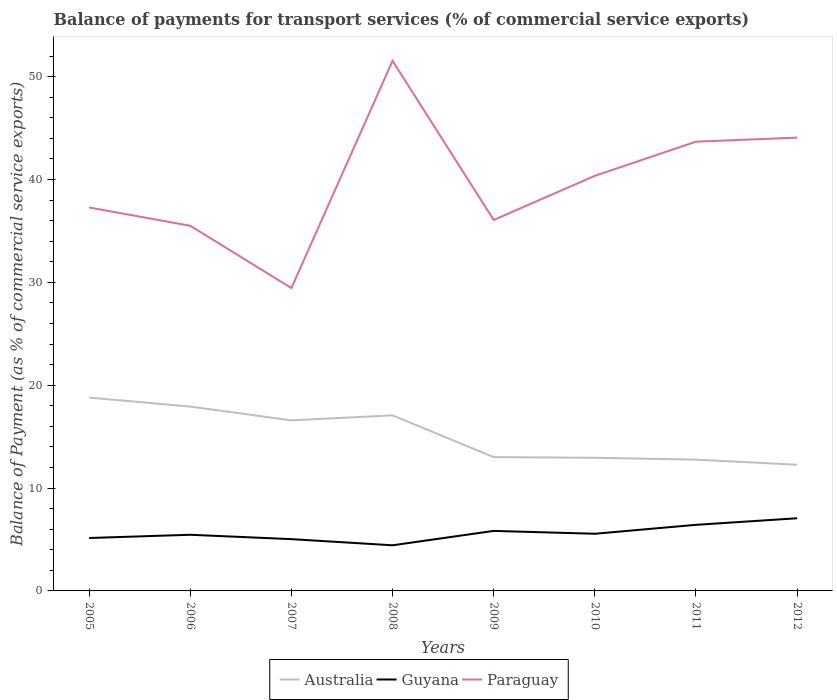How many different coloured lines are there?
Provide a succinct answer. 3. Across all years, what is the maximum balance of payments for transport services in Paraguay?
Ensure brevity in your answer.  29.45. What is the total balance of payments for transport services in Australia in the graph?
Make the answer very short. -0.49. What is the difference between the highest and the second highest balance of payments for transport services in Guyana?
Offer a very short reply. 2.63. Is the balance of payments for transport services in Guyana strictly greater than the balance of payments for transport services in Paraguay over the years?
Provide a short and direct response. Yes. How many lines are there?
Provide a succinct answer. 3. How many years are there in the graph?
Your answer should be compact. 8. What is the difference between two consecutive major ticks on the Y-axis?
Your answer should be very brief. 10. Are the values on the major ticks of Y-axis written in scientific E-notation?
Your answer should be very brief. No. Does the graph contain any zero values?
Make the answer very short. No. What is the title of the graph?
Provide a short and direct response. Balance of payments for transport services (% of commercial service exports). Does "Andorra" appear as one of the legend labels in the graph?
Keep it short and to the point. No. What is the label or title of the Y-axis?
Offer a terse response. Balance of Payment (as % of commercial service exports). What is the Balance of Payment (as % of commercial service exports) in Australia in 2005?
Provide a succinct answer. 18.8. What is the Balance of Payment (as % of commercial service exports) in Guyana in 2005?
Make the answer very short. 5.15. What is the Balance of Payment (as % of commercial service exports) of Paraguay in 2005?
Provide a succinct answer. 37.28. What is the Balance of Payment (as % of commercial service exports) in Australia in 2006?
Your response must be concise. 17.92. What is the Balance of Payment (as % of commercial service exports) in Guyana in 2006?
Make the answer very short. 5.46. What is the Balance of Payment (as % of commercial service exports) in Paraguay in 2006?
Your answer should be compact. 35.5. What is the Balance of Payment (as % of commercial service exports) of Australia in 2007?
Ensure brevity in your answer.  16.58. What is the Balance of Payment (as % of commercial service exports) of Guyana in 2007?
Offer a terse response. 5.03. What is the Balance of Payment (as % of commercial service exports) in Paraguay in 2007?
Provide a succinct answer. 29.45. What is the Balance of Payment (as % of commercial service exports) in Australia in 2008?
Provide a short and direct response. 17.07. What is the Balance of Payment (as % of commercial service exports) of Guyana in 2008?
Ensure brevity in your answer.  4.44. What is the Balance of Payment (as % of commercial service exports) of Paraguay in 2008?
Offer a very short reply. 51.54. What is the Balance of Payment (as % of commercial service exports) in Australia in 2009?
Provide a succinct answer. 13.01. What is the Balance of Payment (as % of commercial service exports) of Guyana in 2009?
Offer a very short reply. 5.84. What is the Balance of Payment (as % of commercial service exports) in Paraguay in 2009?
Provide a succinct answer. 36.07. What is the Balance of Payment (as % of commercial service exports) in Australia in 2010?
Provide a succinct answer. 12.94. What is the Balance of Payment (as % of commercial service exports) of Guyana in 2010?
Your answer should be very brief. 5.56. What is the Balance of Payment (as % of commercial service exports) in Paraguay in 2010?
Keep it short and to the point. 40.36. What is the Balance of Payment (as % of commercial service exports) of Australia in 2011?
Your response must be concise. 12.76. What is the Balance of Payment (as % of commercial service exports) in Guyana in 2011?
Keep it short and to the point. 6.43. What is the Balance of Payment (as % of commercial service exports) of Paraguay in 2011?
Offer a terse response. 43.68. What is the Balance of Payment (as % of commercial service exports) of Australia in 2012?
Your answer should be compact. 12.27. What is the Balance of Payment (as % of commercial service exports) in Guyana in 2012?
Offer a terse response. 7.06. What is the Balance of Payment (as % of commercial service exports) in Paraguay in 2012?
Give a very brief answer. 44.07. Across all years, what is the maximum Balance of Payment (as % of commercial service exports) of Australia?
Provide a short and direct response. 18.8. Across all years, what is the maximum Balance of Payment (as % of commercial service exports) of Guyana?
Ensure brevity in your answer.  7.06. Across all years, what is the maximum Balance of Payment (as % of commercial service exports) in Paraguay?
Your answer should be very brief. 51.54. Across all years, what is the minimum Balance of Payment (as % of commercial service exports) of Australia?
Your answer should be very brief. 12.27. Across all years, what is the minimum Balance of Payment (as % of commercial service exports) of Guyana?
Offer a terse response. 4.44. Across all years, what is the minimum Balance of Payment (as % of commercial service exports) of Paraguay?
Offer a terse response. 29.45. What is the total Balance of Payment (as % of commercial service exports) of Australia in the graph?
Give a very brief answer. 121.36. What is the total Balance of Payment (as % of commercial service exports) of Guyana in the graph?
Give a very brief answer. 44.96. What is the total Balance of Payment (as % of commercial service exports) in Paraguay in the graph?
Your response must be concise. 317.95. What is the difference between the Balance of Payment (as % of commercial service exports) in Australia in 2005 and that in 2006?
Offer a very short reply. 0.87. What is the difference between the Balance of Payment (as % of commercial service exports) in Guyana in 2005 and that in 2006?
Provide a succinct answer. -0.31. What is the difference between the Balance of Payment (as % of commercial service exports) of Paraguay in 2005 and that in 2006?
Provide a succinct answer. 1.78. What is the difference between the Balance of Payment (as % of commercial service exports) of Australia in 2005 and that in 2007?
Your answer should be compact. 2.21. What is the difference between the Balance of Payment (as % of commercial service exports) of Guyana in 2005 and that in 2007?
Give a very brief answer. 0.11. What is the difference between the Balance of Payment (as % of commercial service exports) of Paraguay in 2005 and that in 2007?
Give a very brief answer. 7.84. What is the difference between the Balance of Payment (as % of commercial service exports) of Australia in 2005 and that in 2008?
Your answer should be compact. 1.73. What is the difference between the Balance of Payment (as % of commercial service exports) in Guyana in 2005 and that in 2008?
Your response must be concise. 0.71. What is the difference between the Balance of Payment (as % of commercial service exports) of Paraguay in 2005 and that in 2008?
Your answer should be compact. -14.26. What is the difference between the Balance of Payment (as % of commercial service exports) of Australia in 2005 and that in 2009?
Give a very brief answer. 5.79. What is the difference between the Balance of Payment (as % of commercial service exports) of Guyana in 2005 and that in 2009?
Keep it short and to the point. -0.69. What is the difference between the Balance of Payment (as % of commercial service exports) of Paraguay in 2005 and that in 2009?
Keep it short and to the point. 1.21. What is the difference between the Balance of Payment (as % of commercial service exports) in Australia in 2005 and that in 2010?
Ensure brevity in your answer.  5.85. What is the difference between the Balance of Payment (as % of commercial service exports) of Guyana in 2005 and that in 2010?
Your answer should be very brief. -0.41. What is the difference between the Balance of Payment (as % of commercial service exports) in Paraguay in 2005 and that in 2010?
Give a very brief answer. -3.08. What is the difference between the Balance of Payment (as % of commercial service exports) of Australia in 2005 and that in 2011?
Make the answer very short. 6.03. What is the difference between the Balance of Payment (as % of commercial service exports) in Guyana in 2005 and that in 2011?
Offer a very short reply. -1.28. What is the difference between the Balance of Payment (as % of commercial service exports) in Paraguay in 2005 and that in 2011?
Give a very brief answer. -6.4. What is the difference between the Balance of Payment (as % of commercial service exports) in Australia in 2005 and that in 2012?
Ensure brevity in your answer.  6.53. What is the difference between the Balance of Payment (as % of commercial service exports) in Guyana in 2005 and that in 2012?
Your response must be concise. -1.92. What is the difference between the Balance of Payment (as % of commercial service exports) in Paraguay in 2005 and that in 2012?
Keep it short and to the point. -6.79. What is the difference between the Balance of Payment (as % of commercial service exports) in Australia in 2006 and that in 2007?
Give a very brief answer. 1.34. What is the difference between the Balance of Payment (as % of commercial service exports) of Guyana in 2006 and that in 2007?
Offer a very short reply. 0.42. What is the difference between the Balance of Payment (as % of commercial service exports) of Paraguay in 2006 and that in 2007?
Offer a very short reply. 6.06. What is the difference between the Balance of Payment (as % of commercial service exports) in Australia in 2006 and that in 2008?
Keep it short and to the point. 0.85. What is the difference between the Balance of Payment (as % of commercial service exports) in Guyana in 2006 and that in 2008?
Provide a short and direct response. 1.02. What is the difference between the Balance of Payment (as % of commercial service exports) of Paraguay in 2006 and that in 2008?
Your response must be concise. -16.04. What is the difference between the Balance of Payment (as % of commercial service exports) in Australia in 2006 and that in 2009?
Provide a succinct answer. 4.91. What is the difference between the Balance of Payment (as % of commercial service exports) of Guyana in 2006 and that in 2009?
Offer a very short reply. -0.38. What is the difference between the Balance of Payment (as % of commercial service exports) of Paraguay in 2006 and that in 2009?
Give a very brief answer. -0.56. What is the difference between the Balance of Payment (as % of commercial service exports) in Australia in 2006 and that in 2010?
Provide a short and direct response. 4.98. What is the difference between the Balance of Payment (as % of commercial service exports) in Guyana in 2006 and that in 2010?
Provide a short and direct response. -0.1. What is the difference between the Balance of Payment (as % of commercial service exports) in Paraguay in 2006 and that in 2010?
Your response must be concise. -4.85. What is the difference between the Balance of Payment (as % of commercial service exports) of Australia in 2006 and that in 2011?
Your answer should be compact. 5.16. What is the difference between the Balance of Payment (as % of commercial service exports) in Guyana in 2006 and that in 2011?
Offer a very short reply. -0.97. What is the difference between the Balance of Payment (as % of commercial service exports) in Paraguay in 2006 and that in 2011?
Give a very brief answer. -8.18. What is the difference between the Balance of Payment (as % of commercial service exports) in Australia in 2006 and that in 2012?
Your response must be concise. 5.65. What is the difference between the Balance of Payment (as % of commercial service exports) in Guyana in 2006 and that in 2012?
Make the answer very short. -1.61. What is the difference between the Balance of Payment (as % of commercial service exports) in Paraguay in 2006 and that in 2012?
Your answer should be very brief. -8.57. What is the difference between the Balance of Payment (as % of commercial service exports) of Australia in 2007 and that in 2008?
Provide a short and direct response. -0.49. What is the difference between the Balance of Payment (as % of commercial service exports) in Guyana in 2007 and that in 2008?
Provide a succinct answer. 0.6. What is the difference between the Balance of Payment (as % of commercial service exports) in Paraguay in 2007 and that in 2008?
Your response must be concise. -22.09. What is the difference between the Balance of Payment (as % of commercial service exports) in Australia in 2007 and that in 2009?
Provide a short and direct response. 3.57. What is the difference between the Balance of Payment (as % of commercial service exports) in Guyana in 2007 and that in 2009?
Ensure brevity in your answer.  -0.8. What is the difference between the Balance of Payment (as % of commercial service exports) in Paraguay in 2007 and that in 2009?
Provide a short and direct response. -6.62. What is the difference between the Balance of Payment (as % of commercial service exports) of Australia in 2007 and that in 2010?
Give a very brief answer. 3.64. What is the difference between the Balance of Payment (as % of commercial service exports) of Guyana in 2007 and that in 2010?
Ensure brevity in your answer.  -0.52. What is the difference between the Balance of Payment (as % of commercial service exports) in Paraguay in 2007 and that in 2010?
Your answer should be very brief. -10.91. What is the difference between the Balance of Payment (as % of commercial service exports) of Australia in 2007 and that in 2011?
Your answer should be compact. 3.82. What is the difference between the Balance of Payment (as % of commercial service exports) of Guyana in 2007 and that in 2011?
Keep it short and to the point. -1.39. What is the difference between the Balance of Payment (as % of commercial service exports) in Paraguay in 2007 and that in 2011?
Your response must be concise. -14.23. What is the difference between the Balance of Payment (as % of commercial service exports) in Australia in 2007 and that in 2012?
Offer a very short reply. 4.31. What is the difference between the Balance of Payment (as % of commercial service exports) in Guyana in 2007 and that in 2012?
Give a very brief answer. -2.03. What is the difference between the Balance of Payment (as % of commercial service exports) in Paraguay in 2007 and that in 2012?
Your answer should be very brief. -14.62. What is the difference between the Balance of Payment (as % of commercial service exports) of Australia in 2008 and that in 2009?
Provide a short and direct response. 4.06. What is the difference between the Balance of Payment (as % of commercial service exports) in Guyana in 2008 and that in 2009?
Ensure brevity in your answer.  -1.4. What is the difference between the Balance of Payment (as % of commercial service exports) in Paraguay in 2008 and that in 2009?
Your answer should be very brief. 15.47. What is the difference between the Balance of Payment (as % of commercial service exports) in Australia in 2008 and that in 2010?
Provide a short and direct response. 4.12. What is the difference between the Balance of Payment (as % of commercial service exports) of Guyana in 2008 and that in 2010?
Your answer should be compact. -1.12. What is the difference between the Balance of Payment (as % of commercial service exports) of Paraguay in 2008 and that in 2010?
Your answer should be very brief. 11.18. What is the difference between the Balance of Payment (as % of commercial service exports) of Australia in 2008 and that in 2011?
Your answer should be very brief. 4.31. What is the difference between the Balance of Payment (as % of commercial service exports) of Guyana in 2008 and that in 2011?
Provide a short and direct response. -1.99. What is the difference between the Balance of Payment (as % of commercial service exports) in Paraguay in 2008 and that in 2011?
Keep it short and to the point. 7.86. What is the difference between the Balance of Payment (as % of commercial service exports) of Australia in 2008 and that in 2012?
Offer a very short reply. 4.8. What is the difference between the Balance of Payment (as % of commercial service exports) in Guyana in 2008 and that in 2012?
Your answer should be very brief. -2.63. What is the difference between the Balance of Payment (as % of commercial service exports) of Paraguay in 2008 and that in 2012?
Provide a short and direct response. 7.47. What is the difference between the Balance of Payment (as % of commercial service exports) of Australia in 2009 and that in 2010?
Make the answer very short. 0.06. What is the difference between the Balance of Payment (as % of commercial service exports) of Guyana in 2009 and that in 2010?
Offer a terse response. 0.28. What is the difference between the Balance of Payment (as % of commercial service exports) in Paraguay in 2009 and that in 2010?
Your response must be concise. -4.29. What is the difference between the Balance of Payment (as % of commercial service exports) in Australia in 2009 and that in 2011?
Provide a succinct answer. 0.25. What is the difference between the Balance of Payment (as % of commercial service exports) of Guyana in 2009 and that in 2011?
Your answer should be compact. -0.59. What is the difference between the Balance of Payment (as % of commercial service exports) of Paraguay in 2009 and that in 2011?
Provide a succinct answer. -7.61. What is the difference between the Balance of Payment (as % of commercial service exports) of Australia in 2009 and that in 2012?
Ensure brevity in your answer.  0.74. What is the difference between the Balance of Payment (as % of commercial service exports) in Guyana in 2009 and that in 2012?
Ensure brevity in your answer.  -1.23. What is the difference between the Balance of Payment (as % of commercial service exports) in Paraguay in 2009 and that in 2012?
Give a very brief answer. -8. What is the difference between the Balance of Payment (as % of commercial service exports) of Australia in 2010 and that in 2011?
Your answer should be compact. 0.18. What is the difference between the Balance of Payment (as % of commercial service exports) in Guyana in 2010 and that in 2011?
Offer a terse response. -0.87. What is the difference between the Balance of Payment (as % of commercial service exports) of Paraguay in 2010 and that in 2011?
Offer a terse response. -3.32. What is the difference between the Balance of Payment (as % of commercial service exports) in Australia in 2010 and that in 2012?
Keep it short and to the point. 0.68. What is the difference between the Balance of Payment (as % of commercial service exports) in Guyana in 2010 and that in 2012?
Your answer should be compact. -1.51. What is the difference between the Balance of Payment (as % of commercial service exports) in Paraguay in 2010 and that in 2012?
Make the answer very short. -3.71. What is the difference between the Balance of Payment (as % of commercial service exports) in Australia in 2011 and that in 2012?
Your response must be concise. 0.49. What is the difference between the Balance of Payment (as % of commercial service exports) of Guyana in 2011 and that in 2012?
Your answer should be very brief. -0.64. What is the difference between the Balance of Payment (as % of commercial service exports) of Paraguay in 2011 and that in 2012?
Your answer should be compact. -0.39. What is the difference between the Balance of Payment (as % of commercial service exports) of Australia in 2005 and the Balance of Payment (as % of commercial service exports) of Guyana in 2006?
Provide a succinct answer. 13.34. What is the difference between the Balance of Payment (as % of commercial service exports) of Australia in 2005 and the Balance of Payment (as % of commercial service exports) of Paraguay in 2006?
Ensure brevity in your answer.  -16.71. What is the difference between the Balance of Payment (as % of commercial service exports) of Guyana in 2005 and the Balance of Payment (as % of commercial service exports) of Paraguay in 2006?
Ensure brevity in your answer.  -30.36. What is the difference between the Balance of Payment (as % of commercial service exports) of Australia in 2005 and the Balance of Payment (as % of commercial service exports) of Guyana in 2007?
Give a very brief answer. 13.76. What is the difference between the Balance of Payment (as % of commercial service exports) of Australia in 2005 and the Balance of Payment (as % of commercial service exports) of Paraguay in 2007?
Provide a succinct answer. -10.65. What is the difference between the Balance of Payment (as % of commercial service exports) in Guyana in 2005 and the Balance of Payment (as % of commercial service exports) in Paraguay in 2007?
Your answer should be compact. -24.3. What is the difference between the Balance of Payment (as % of commercial service exports) of Australia in 2005 and the Balance of Payment (as % of commercial service exports) of Guyana in 2008?
Offer a very short reply. 14.36. What is the difference between the Balance of Payment (as % of commercial service exports) in Australia in 2005 and the Balance of Payment (as % of commercial service exports) in Paraguay in 2008?
Offer a terse response. -32.74. What is the difference between the Balance of Payment (as % of commercial service exports) of Guyana in 2005 and the Balance of Payment (as % of commercial service exports) of Paraguay in 2008?
Ensure brevity in your answer.  -46.4. What is the difference between the Balance of Payment (as % of commercial service exports) in Australia in 2005 and the Balance of Payment (as % of commercial service exports) in Guyana in 2009?
Your answer should be compact. 12.96. What is the difference between the Balance of Payment (as % of commercial service exports) in Australia in 2005 and the Balance of Payment (as % of commercial service exports) in Paraguay in 2009?
Offer a very short reply. -17.27. What is the difference between the Balance of Payment (as % of commercial service exports) in Guyana in 2005 and the Balance of Payment (as % of commercial service exports) in Paraguay in 2009?
Make the answer very short. -30.92. What is the difference between the Balance of Payment (as % of commercial service exports) of Australia in 2005 and the Balance of Payment (as % of commercial service exports) of Guyana in 2010?
Your answer should be very brief. 13.24. What is the difference between the Balance of Payment (as % of commercial service exports) in Australia in 2005 and the Balance of Payment (as % of commercial service exports) in Paraguay in 2010?
Keep it short and to the point. -21.56. What is the difference between the Balance of Payment (as % of commercial service exports) in Guyana in 2005 and the Balance of Payment (as % of commercial service exports) in Paraguay in 2010?
Your response must be concise. -35.21. What is the difference between the Balance of Payment (as % of commercial service exports) in Australia in 2005 and the Balance of Payment (as % of commercial service exports) in Guyana in 2011?
Give a very brief answer. 12.37. What is the difference between the Balance of Payment (as % of commercial service exports) of Australia in 2005 and the Balance of Payment (as % of commercial service exports) of Paraguay in 2011?
Provide a succinct answer. -24.88. What is the difference between the Balance of Payment (as % of commercial service exports) of Guyana in 2005 and the Balance of Payment (as % of commercial service exports) of Paraguay in 2011?
Offer a terse response. -38.53. What is the difference between the Balance of Payment (as % of commercial service exports) of Australia in 2005 and the Balance of Payment (as % of commercial service exports) of Guyana in 2012?
Provide a succinct answer. 11.73. What is the difference between the Balance of Payment (as % of commercial service exports) of Australia in 2005 and the Balance of Payment (as % of commercial service exports) of Paraguay in 2012?
Provide a succinct answer. -25.28. What is the difference between the Balance of Payment (as % of commercial service exports) of Guyana in 2005 and the Balance of Payment (as % of commercial service exports) of Paraguay in 2012?
Your answer should be very brief. -38.93. What is the difference between the Balance of Payment (as % of commercial service exports) in Australia in 2006 and the Balance of Payment (as % of commercial service exports) in Guyana in 2007?
Keep it short and to the point. 12.89. What is the difference between the Balance of Payment (as % of commercial service exports) of Australia in 2006 and the Balance of Payment (as % of commercial service exports) of Paraguay in 2007?
Your answer should be compact. -11.52. What is the difference between the Balance of Payment (as % of commercial service exports) in Guyana in 2006 and the Balance of Payment (as % of commercial service exports) in Paraguay in 2007?
Keep it short and to the point. -23.99. What is the difference between the Balance of Payment (as % of commercial service exports) in Australia in 2006 and the Balance of Payment (as % of commercial service exports) in Guyana in 2008?
Provide a succinct answer. 13.49. What is the difference between the Balance of Payment (as % of commercial service exports) of Australia in 2006 and the Balance of Payment (as % of commercial service exports) of Paraguay in 2008?
Your answer should be very brief. -33.62. What is the difference between the Balance of Payment (as % of commercial service exports) in Guyana in 2006 and the Balance of Payment (as % of commercial service exports) in Paraguay in 2008?
Ensure brevity in your answer.  -46.08. What is the difference between the Balance of Payment (as % of commercial service exports) in Australia in 2006 and the Balance of Payment (as % of commercial service exports) in Guyana in 2009?
Your response must be concise. 12.09. What is the difference between the Balance of Payment (as % of commercial service exports) in Australia in 2006 and the Balance of Payment (as % of commercial service exports) in Paraguay in 2009?
Make the answer very short. -18.14. What is the difference between the Balance of Payment (as % of commercial service exports) in Guyana in 2006 and the Balance of Payment (as % of commercial service exports) in Paraguay in 2009?
Provide a succinct answer. -30.61. What is the difference between the Balance of Payment (as % of commercial service exports) in Australia in 2006 and the Balance of Payment (as % of commercial service exports) in Guyana in 2010?
Give a very brief answer. 12.37. What is the difference between the Balance of Payment (as % of commercial service exports) of Australia in 2006 and the Balance of Payment (as % of commercial service exports) of Paraguay in 2010?
Give a very brief answer. -22.43. What is the difference between the Balance of Payment (as % of commercial service exports) in Guyana in 2006 and the Balance of Payment (as % of commercial service exports) in Paraguay in 2010?
Keep it short and to the point. -34.9. What is the difference between the Balance of Payment (as % of commercial service exports) of Australia in 2006 and the Balance of Payment (as % of commercial service exports) of Guyana in 2011?
Give a very brief answer. 11.5. What is the difference between the Balance of Payment (as % of commercial service exports) in Australia in 2006 and the Balance of Payment (as % of commercial service exports) in Paraguay in 2011?
Provide a short and direct response. -25.76. What is the difference between the Balance of Payment (as % of commercial service exports) of Guyana in 2006 and the Balance of Payment (as % of commercial service exports) of Paraguay in 2011?
Offer a terse response. -38.22. What is the difference between the Balance of Payment (as % of commercial service exports) in Australia in 2006 and the Balance of Payment (as % of commercial service exports) in Guyana in 2012?
Make the answer very short. 10.86. What is the difference between the Balance of Payment (as % of commercial service exports) of Australia in 2006 and the Balance of Payment (as % of commercial service exports) of Paraguay in 2012?
Your answer should be compact. -26.15. What is the difference between the Balance of Payment (as % of commercial service exports) in Guyana in 2006 and the Balance of Payment (as % of commercial service exports) in Paraguay in 2012?
Keep it short and to the point. -38.61. What is the difference between the Balance of Payment (as % of commercial service exports) of Australia in 2007 and the Balance of Payment (as % of commercial service exports) of Guyana in 2008?
Offer a very short reply. 12.15. What is the difference between the Balance of Payment (as % of commercial service exports) of Australia in 2007 and the Balance of Payment (as % of commercial service exports) of Paraguay in 2008?
Provide a succinct answer. -34.96. What is the difference between the Balance of Payment (as % of commercial service exports) of Guyana in 2007 and the Balance of Payment (as % of commercial service exports) of Paraguay in 2008?
Provide a short and direct response. -46.51. What is the difference between the Balance of Payment (as % of commercial service exports) of Australia in 2007 and the Balance of Payment (as % of commercial service exports) of Guyana in 2009?
Provide a succinct answer. 10.75. What is the difference between the Balance of Payment (as % of commercial service exports) in Australia in 2007 and the Balance of Payment (as % of commercial service exports) in Paraguay in 2009?
Offer a terse response. -19.48. What is the difference between the Balance of Payment (as % of commercial service exports) in Guyana in 2007 and the Balance of Payment (as % of commercial service exports) in Paraguay in 2009?
Provide a short and direct response. -31.03. What is the difference between the Balance of Payment (as % of commercial service exports) in Australia in 2007 and the Balance of Payment (as % of commercial service exports) in Guyana in 2010?
Your response must be concise. 11.03. What is the difference between the Balance of Payment (as % of commercial service exports) in Australia in 2007 and the Balance of Payment (as % of commercial service exports) in Paraguay in 2010?
Your response must be concise. -23.77. What is the difference between the Balance of Payment (as % of commercial service exports) in Guyana in 2007 and the Balance of Payment (as % of commercial service exports) in Paraguay in 2010?
Offer a very short reply. -35.32. What is the difference between the Balance of Payment (as % of commercial service exports) in Australia in 2007 and the Balance of Payment (as % of commercial service exports) in Guyana in 2011?
Your answer should be compact. 10.16. What is the difference between the Balance of Payment (as % of commercial service exports) of Australia in 2007 and the Balance of Payment (as % of commercial service exports) of Paraguay in 2011?
Your answer should be very brief. -27.1. What is the difference between the Balance of Payment (as % of commercial service exports) of Guyana in 2007 and the Balance of Payment (as % of commercial service exports) of Paraguay in 2011?
Give a very brief answer. -38.65. What is the difference between the Balance of Payment (as % of commercial service exports) of Australia in 2007 and the Balance of Payment (as % of commercial service exports) of Guyana in 2012?
Offer a very short reply. 9.52. What is the difference between the Balance of Payment (as % of commercial service exports) in Australia in 2007 and the Balance of Payment (as % of commercial service exports) in Paraguay in 2012?
Offer a very short reply. -27.49. What is the difference between the Balance of Payment (as % of commercial service exports) of Guyana in 2007 and the Balance of Payment (as % of commercial service exports) of Paraguay in 2012?
Ensure brevity in your answer.  -39.04. What is the difference between the Balance of Payment (as % of commercial service exports) in Australia in 2008 and the Balance of Payment (as % of commercial service exports) in Guyana in 2009?
Keep it short and to the point. 11.23. What is the difference between the Balance of Payment (as % of commercial service exports) in Australia in 2008 and the Balance of Payment (as % of commercial service exports) in Paraguay in 2009?
Your answer should be compact. -19. What is the difference between the Balance of Payment (as % of commercial service exports) in Guyana in 2008 and the Balance of Payment (as % of commercial service exports) in Paraguay in 2009?
Provide a succinct answer. -31.63. What is the difference between the Balance of Payment (as % of commercial service exports) of Australia in 2008 and the Balance of Payment (as % of commercial service exports) of Guyana in 2010?
Your answer should be compact. 11.51. What is the difference between the Balance of Payment (as % of commercial service exports) of Australia in 2008 and the Balance of Payment (as % of commercial service exports) of Paraguay in 2010?
Your response must be concise. -23.29. What is the difference between the Balance of Payment (as % of commercial service exports) in Guyana in 2008 and the Balance of Payment (as % of commercial service exports) in Paraguay in 2010?
Give a very brief answer. -35.92. What is the difference between the Balance of Payment (as % of commercial service exports) in Australia in 2008 and the Balance of Payment (as % of commercial service exports) in Guyana in 2011?
Your answer should be compact. 10.64. What is the difference between the Balance of Payment (as % of commercial service exports) in Australia in 2008 and the Balance of Payment (as % of commercial service exports) in Paraguay in 2011?
Provide a succinct answer. -26.61. What is the difference between the Balance of Payment (as % of commercial service exports) of Guyana in 2008 and the Balance of Payment (as % of commercial service exports) of Paraguay in 2011?
Your response must be concise. -39.24. What is the difference between the Balance of Payment (as % of commercial service exports) in Australia in 2008 and the Balance of Payment (as % of commercial service exports) in Guyana in 2012?
Provide a short and direct response. 10. What is the difference between the Balance of Payment (as % of commercial service exports) in Australia in 2008 and the Balance of Payment (as % of commercial service exports) in Paraguay in 2012?
Offer a very short reply. -27. What is the difference between the Balance of Payment (as % of commercial service exports) in Guyana in 2008 and the Balance of Payment (as % of commercial service exports) in Paraguay in 2012?
Offer a very short reply. -39.64. What is the difference between the Balance of Payment (as % of commercial service exports) in Australia in 2009 and the Balance of Payment (as % of commercial service exports) in Guyana in 2010?
Provide a succinct answer. 7.45. What is the difference between the Balance of Payment (as % of commercial service exports) of Australia in 2009 and the Balance of Payment (as % of commercial service exports) of Paraguay in 2010?
Your answer should be very brief. -27.35. What is the difference between the Balance of Payment (as % of commercial service exports) in Guyana in 2009 and the Balance of Payment (as % of commercial service exports) in Paraguay in 2010?
Your answer should be compact. -34.52. What is the difference between the Balance of Payment (as % of commercial service exports) in Australia in 2009 and the Balance of Payment (as % of commercial service exports) in Guyana in 2011?
Your answer should be very brief. 6.58. What is the difference between the Balance of Payment (as % of commercial service exports) in Australia in 2009 and the Balance of Payment (as % of commercial service exports) in Paraguay in 2011?
Your answer should be very brief. -30.67. What is the difference between the Balance of Payment (as % of commercial service exports) in Guyana in 2009 and the Balance of Payment (as % of commercial service exports) in Paraguay in 2011?
Keep it short and to the point. -37.84. What is the difference between the Balance of Payment (as % of commercial service exports) in Australia in 2009 and the Balance of Payment (as % of commercial service exports) in Guyana in 2012?
Make the answer very short. 5.95. What is the difference between the Balance of Payment (as % of commercial service exports) of Australia in 2009 and the Balance of Payment (as % of commercial service exports) of Paraguay in 2012?
Offer a very short reply. -31.06. What is the difference between the Balance of Payment (as % of commercial service exports) in Guyana in 2009 and the Balance of Payment (as % of commercial service exports) in Paraguay in 2012?
Provide a short and direct response. -38.24. What is the difference between the Balance of Payment (as % of commercial service exports) of Australia in 2010 and the Balance of Payment (as % of commercial service exports) of Guyana in 2011?
Provide a succinct answer. 6.52. What is the difference between the Balance of Payment (as % of commercial service exports) of Australia in 2010 and the Balance of Payment (as % of commercial service exports) of Paraguay in 2011?
Provide a succinct answer. -30.74. What is the difference between the Balance of Payment (as % of commercial service exports) in Guyana in 2010 and the Balance of Payment (as % of commercial service exports) in Paraguay in 2011?
Give a very brief answer. -38.12. What is the difference between the Balance of Payment (as % of commercial service exports) in Australia in 2010 and the Balance of Payment (as % of commercial service exports) in Guyana in 2012?
Give a very brief answer. 5.88. What is the difference between the Balance of Payment (as % of commercial service exports) of Australia in 2010 and the Balance of Payment (as % of commercial service exports) of Paraguay in 2012?
Your answer should be very brief. -31.13. What is the difference between the Balance of Payment (as % of commercial service exports) of Guyana in 2010 and the Balance of Payment (as % of commercial service exports) of Paraguay in 2012?
Offer a very short reply. -38.51. What is the difference between the Balance of Payment (as % of commercial service exports) in Australia in 2011 and the Balance of Payment (as % of commercial service exports) in Guyana in 2012?
Your answer should be very brief. 5.7. What is the difference between the Balance of Payment (as % of commercial service exports) in Australia in 2011 and the Balance of Payment (as % of commercial service exports) in Paraguay in 2012?
Offer a very short reply. -31.31. What is the difference between the Balance of Payment (as % of commercial service exports) in Guyana in 2011 and the Balance of Payment (as % of commercial service exports) in Paraguay in 2012?
Your answer should be very brief. -37.65. What is the average Balance of Payment (as % of commercial service exports) in Australia per year?
Give a very brief answer. 15.17. What is the average Balance of Payment (as % of commercial service exports) of Guyana per year?
Ensure brevity in your answer.  5.62. What is the average Balance of Payment (as % of commercial service exports) in Paraguay per year?
Keep it short and to the point. 39.74. In the year 2005, what is the difference between the Balance of Payment (as % of commercial service exports) of Australia and Balance of Payment (as % of commercial service exports) of Guyana?
Your answer should be compact. 13.65. In the year 2005, what is the difference between the Balance of Payment (as % of commercial service exports) in Australia and Balance of Payment (as % of commercial service exports) in Paraguay?
Your answer should be compact. -18.49. In the year 2005, what is the difference between the Balance of Payment (as % of commercial service exports) in Guyana and Balance of Payment (as % of commercial service exports) in Paraguay?
Ensure brevity in your answer.  -32.14. In the year 2006, what is the difference between the Balance of Payment (as % of commercial service exports) of Australia and Balance of Payment (as % of commercial service exports) of Guyana?
Ensure brevity in your answer.  12.46. In the year 2006, what is the difference between the Balance of Payment (as % of commercial service exports) of Australia and Balance of Payment (as % of commercial service exports) of Paraguay?
Offer a very short reply. -17.58. In the year 2006, what is the difference between the Balance of Payment (as % of commercial service exports) of Guyana and Balance of Payment (as % of commercial service exports) of Paraguay?
Keep it short and to the point. -30.04. In the year 2007, what is the difference between the Balance of Payment (as % of commercial service exports) in Australia and Balance of Payment (as % of commercial service exports) in Guyana?
Provide a short and direct response. 11.55. In the year 2007, what is the difference between the Balance of Payment (as % of commercial service exports) of Australia and Balance of Payment (as % of commercial service exports) of Paraguay?
Your answer should be very brief. -12.86. In the year 2007, what is the difference between the Balance of Payment (as % of commercial service exports) in Guyana and Balance of Payment (as % of commercial service exports) in Paraguay?
Offer a very short reply. -24.41. In the year 2008, what is the difference between the Balance of Payment (as % of commercial service exports) of Australia and Balance of Payment (as % of commercial service exports) of Guyana?
Make the answer very short. 12.63. In the year 2008, what is the difference between the Balance of Payment (as % of commercial service exports) of Australia and Balance of Payment (as % of commercial service exports) of Paraguay?
Give a very brief answer. -34.47. In the year 2008, what is the difference between the Balance of Payment (as % of commercial service exports) in Guyana and Balance of Payment (as % of commercial service exports) in Paraguay?
Ensure brevity in your answer.  -47.1. In the year 2009, what is the difference between the Balance of Payment (as % of commercial service exports) of Australia and Balance of Payment (as % of commercial service exports) of Guyana?
Make the answer very short. 7.17. In the year 2009, what is the difference between the Balance of Payment (as % of commercial service exports) of Australia and Balance of Payment (as % of commercial service exports) of Paraguay?
Keep it short and to the point. -23.06. In the year 2009, what is the difference between the Balance of Payment (as % of commercial service exports) of Guyana and Balance of Payment (as % of commercial service exports) of Paraguay?
Your answer should be compact. -30.23. In the year 2010, what is the difference between the Balance of Payment (as % of commercial service exports) in Australia and Balance of Payment (as % of commercial service exports) in Guyana?
Keep it short and to the point. 7.39. In the year 2010, what is the difference between the Balance of Payment (as % of commercial service exports) of Australia and Balance of Payment (as % of commercial service exports) of Paraguay?
Offer a terse response. -27.41. In the year 2010, what is the difference between the Balance of Payment (as % of commercial service exports) in Guyana and Balance of Payment (as % of commercial service exports) in Paraguay?
Your answer should be compact. -34.8. In the year 2011, what is the difference between the Balance of Payment (as % of commercial service exports) in Australia and Balance of Payment (as % of commercial service exports) in Guyana?
Offer a terse response. 6.34. In the year 2011, what is the difference between the Balance of Payment (as % of commercial service exports) of Australia and Balance of Payment (as % of commercial service exports) of Paraguay?
Make the answer very short. -30.92. In the year 2011, what is the difference between the Balance of Payment (as % of commercial service exports) in Guyana and Balance of Payment (as % of commercial service exports) in Paraguay?
Give a very brief answer. -37.25. In the year 2012, what is the difference between the Balance of Payment (as % of commercial service exports) of Australia and Balance of Payment (as % of commercial service exports) of Guyana?
Your answer should be compact. 5.2. In the year 2012, what is the difference between the Balance of Payment (as % of commercial service exports) of Australia and Balance of Payment (as % of commercial service exports) of Paraguay?
Offer a very short reply. -31.8. In the year 2012, what is the difference between the Balance of Payment (as % of commercial service exports) in Guyana and Balance of Payment (as % of commercial service exports) in Paraguay?
Your answer should be very brief. -37.01. What is the ratio of the Balance of Payment (as % of commercial service exports) in Australia in 2005 to that in 2006?
Keep it short and to the point. 1.05. What is the ratio of the Balance of Payment (as % of commercial service exports) in Guyana in 2005 to that in 2006?
Keep it short and to the point. 0.94. What is the ratio of the Balance of Payment (as % of commercial service exports) of Paraguay in 2005 to that in 2006?
Your response must be concise. 1.05. What is the ratio of the Balance of Payment (as % of commercial service exports) of Australia in 2005 to that in 2007?
Offer a terse response. 1.13. What is the ratio of the Balance of Payment (as % of commercial service exports) of Guyana in 2005 to that in 2007?
Your answer should be compact. 1.02. What is the ratio of the Balance of Payment (as % of commercial service exports) of Paraguay in 2005 to that in 2007?
Make the answer very short. 1.27. What is the ratio of the Balance of Payment (as % of commercial service exports) of Australia in 2005 to that in 2008?
Ensure brevity in your answer.  1.1. What is the ratio of the Balance of Payment (as % of commercial service exports) in Guyana in 2005 to that in 2008?
Offer a very short reply. 1.16. What is the ratio of the Balance of Payment (as % of commercial service exports) of Paraguay in 2005 to that in 2008?
Make the answer very short. 0.72. What is the ratio of the Balance of Payment (as % of commercial service exports) of Australia in 2005 to that in 2009?
Your answer should be compact. 1.44. What is the ratio of the Balance of Payment (as % of commercial service exports) in Guyana in 2005 to that in 2009?
Make the answer very short. 0.88. What is the ratio of the Balance of Payment (as % of commercial service exports) of Paraguay in 2005 to that in 2009?
Offer a terse response. 1.03. What is the ratio of the Balance of Payment (as % of commercial service exports) of Australia in 2005 to that in 2010?
Provide a short and direct response. 1.45. What is the ratio of the Balance of Payment (as % of commercial service exports) in Guyana in 2005 to that in 2010?
Provide a succinct answer. 0.93. What is the ratio of the Balance of Payment (as % of commercial service exports) of Paraguay in 2005 to that in 2010?
Make the answer very short. 0.92. What is the ratio of the Balance of Payment (as % of commercial service exports) of Australia in 2005 to that in 2011?
Your response must be concise. 1.47. What is the ratio of the Balance of Payment (as % of commercial service exports) in Guyana in 2005 to that in 2011?
Provide a succinct answer. 0.8. What is the ratio of the Balance of Payment (as % of commercial service exports) in Paraguay in 2005 to that in 2011?
Offer a terse response. 0.85. What is the ratio of the Balance of Payment (as % of commercial service exports) in Australia in 2005 to that in 2012?
Make the answer very short. 1.53. What is the ratio of the Balance of Payment (as % of commercial service exports) in Guyana in 2005 to that in 2012?
Ensure brevity in your answer.  0.73. What is the ratio of the Balance of Payment (as % of commercial service exports) in Paraguay in 2005 to that in 2012?
Your response must be concise. 0.85. What is the ratio of the Balance of Payment (as % of commercial service exports) in Australia in 2006 to that in 2007?
Offer a very short reply. 1.08. What is the ratio of the Balance of Payment (as % of commercial service exports) of Guyana in 2006 to that in 2007?
Your response must be concise. 1.08. What is the ratio of the Balance of Payment (as % of commercial service exports) of Paraguay in 2006 to that in 2007?
Provide a short and direct response. 1.21. What is the ratio of the Balance of Payment (as % of commercial service exports) of Guyana in 2006 to that in 2008?
Your answer should be very brief. 1.23. What is the ratio of the Balance of Payment (as % of commercial service exports) in Paraguay in 2006 to that in 2008?
Give a very brief answer. 0.69. What is the ratio of the Balance of Payment (as % of commercial service exports) in Australia in 2006 to that in 2009?
Your answer should be compact. 1.38. What is the ratio of the Balance of Payment (as % of commercial service exports) in Guyana in 2006 to that in 2009?
Your answer should be compact. 0.94. What is the ratio of the Balance of Payment (as % of commercial service exports) in Paraguay in 2006 to that in 2009?
Offer a very short reply. 0.98. What is the ratio of the Balance of Payment (as % of commercial service exports) of Australia in 2006 to that in 2010?
Your answer should be compact. 1.38. What is the ratio of the Balance of Payment (as % of commercial service exports) of Guyana in 2006 to that in 2010?
Offer a very short reply. 0.98. What is the ratio of the Balance of Payment (as % of commercial service exports) of Paraguay in 2006 to that in 2010?
Ensure brevity in your answer.  0.88. What is the ratio of the Balance of Payment (as % of commercial service exports) of Australia in 2006 to that in 2011?
Offer a terse response. 1.4. What is the ratio of the Balance of Payment (as % of commercial service exports) in Guyana in 2006 to that in 2011?
Offer a terse response. 0.85. What is the ratio of the Balance of Payment (as % of commercial service exports) of Paraguay in 2006 to that in 2011?
Offer a very short reply. 0.81. What is the ratio of the Balance of Payment (as % of commercial service exports) of Australia in 2006 to that in 2012?
Ensure brevity in your answer.  1.46. What is the ratio of the Balance of Payment (as % of commercial service exports) of Guyana in 2006 to that in 2012?
Ensure brevity in your answer.  0.77. What is the ratio of the Balance of Payment (as % of commercial service exports) of Paraguay in 2006 to that in 2012?
Provide a short and direct response. 0.81. What is the ratio of the Balance of Payment (as % of commercial service exports) in Australia in 2007 to that in 2008?
Provide a short and direct response. 0.97. What is the ratio of the Balance of Payment (as % of commercial service exports) in Guyana in 2007 to that in 2008?
Your answer should be compact. 1.13. What is the ratio of the Balance of Payment (as % of commercial service exports) in Paraguay in 2007 to that in 2008?
Make the answer very short. 0.57. What is the ratio of the Balance of Payment (as % of commercial service exports) in Australia in 2007 to that in 2009?
Your answer should be very brief. 1.27. What is the ratio of the Balance of Payment (as % of commercial service exports) of Guyana in 2007 to that in 2009?
Make the answer very short. 0.86. What is the ratio of the Balance of Payment (as % of commercial service exports) in Paraguay in 2007 to that in 2009?
Provide a succinct answer. 0.82. What is the ratio of the Balance of Payment (as % of commercial service exports) in Australia in 2007 to that in 2010?
Your answer should be compact. 1.28. What is the ratio of the Balance of Payment (as % of commercial service exports) of Guyana in 2007 to that in 2010?
Provide a succinct answer. 0.91. What is the ratio of the Balance of Payment (as % of commercial service exports) of Paraguay in 2007 to that in 2010?
Ensure brevity in your answer.  0.73. What is the ratio of the Balance of Payment (as % of commercial service exports) of Australia in 2007 to that in 2011?
Make the answer very short. 1.3. What is the ratio of the Balance of Payment (as % of commercial service exports) of Guyana in 2007 to that in 2011?
Your answer should be compact. 0.78. What is the ratio of the Balance of Payment (as % of commercial service exports) in Paraguay in 2007 to that in 2011?
Offer a very short reply. 0.67. What is the ratio of the Balance of Payment (as % of commercial service exports) in Australia in 2007 to that in 2012?
Your answer should be compact. 1.35. What is the ratio of the Balance of Payment (as % of commercial service exports) in Guyana in 2007 to that in 2012?
Keep it short and to the point. 0.71. What is the ratio of the Balance of Payment (as % of commercial service exports) of Paraguay in 2007 to that in 2012?
Provide a short and direct response. 0.67. What is the ratio of the Balance of Payment (as % of commercial service exports) of Australia in 2008 to that in 2009?
Keep it short and to the point. 1.31. What is the ratio of the Balance of Payment (as % of commercial service exports) of Guyana in 2008 to that in 2009?
Give a very brief answer. 0.76. What is the ratio of the Balance of Payment (as % of commercial service exports) in Paraguay in 2008 to that in 2009?
Ensure brevity in your answer.  1.43. What is the ratio of the Balance of Payment (as % of commercial service exports) in Australia in 2008 to that in 2010?
Keep it short and to the point. 1.32. What is the ratio of the Balance of Payment (as % of commercial service exports) in Guyana in 2008 to that in 2010?
Offer a terse response. 0.8. What is the ratio of the Balance of Payment (as % of commercial service exports) of Paraguay in 2008 to that in 2010?
Keep it short and to the point. 1.28. What is the ratio of the Balance of Payment (as % of commercial service exports) of Australia in 2008 to that in 2011?
Your response must be concise. 1.34. What is the ratio of the Balance of Payment (as % of commercial service exports) in Guyana in 2008 to that in 2011?
Offer a terse response. 0.69. What is the ratio of the Balance of Payment (as % of commercial service exports) of Paraguay in 2008 to that in 2011?
Provide a short and direct response. 1.18. What is the ratio of the Balance of Payment (as % of commercial service exports) in Australia in 2008 to that in 2012?
Your answer should be compact. 1.39. What is the ratio of the Balance of Payment (as % of commercial service exports) in Guyana in 2008 to that in 2012?
Your answer should be very brief. 0.63. What is the ratio of the Balance of Payment (as % of commercial service exports) of Paraguay in 2008 to that in 2012?
Provide a short and direct response. 1.17. What is the ratio of the Balance of Payment (as % of commercial service exports) of Australia in 2009 to that in 2010?
Your response must be concise. 1. What is the ratio of the Balance of Payment (as % of commercial service exports) of Guyana in 2009 to that in 2010?
Offer a very short reply. 1.05. What is the ratio of the Balance of Payment (as % of commercial service exports) in Paraguay in 2009 to that in 2010?
Your answer should be very brief. 0.89. What is the ratio of the Balance of Payment (as % of commercial service exports) of Australia in 2009 to that in 2011?
Ensure brevity in your answer.  1.02. What is the ratio of the Balance of Payment (as % of commercial service exports) in Guyana in 2009 to that in 2011?
Your answer should be compact. 0.91. What is the ratio of the Balance of Payment (as % of commercial service exports) in Paraguay in 2009 to that in 2011?
Offer a terse response. 0.83. What is the ratio of the Balance of Payment (as % of commercial service exports) of Australia in 2009 to that in 2012?
Your answer should be compact. 1.06. What is the ratio of the Balance of Payment (as % of commercial service exports) in Guyana in 2009 to that in 2012?
Ensure brevity in your answer.  0.83. What is the ratio of the Balance of Payment (as % of commercial service exports) of Paraguay in 2009 to that in 2012?
Your answer should be compact. 0.82. What is the ratio of the Balance of Payment (as % of commercial service exports) in Australia in 2010 to that in 2011?
Give a very brief answer. 1.01. What is the ratio of the Balance of Payment (as % of commercial service exports) of Guyana in 2010 to that in 2011?
Provide a short and direct response. 0.86. What is the ratio of the Balance of Payment (as % of commercial service exports) of Paraguay in 2010 to that in 2011?
Your response must be concise. 0.92. What is the ratio of the Balance of Payment (as % of commercial service exports) in Australia in 2010 to that in 2012?
Offer a very short reply. 1.06. What is the ratio of the Balance of Payment (as % of commercial service exports) in Guyana in 2010 to that in 2012?
Provide a succinct answer. 0.79. What is the ratio of the Balance of Payment (as % of commercial service exports) of Paraguay in 2010 to that in 2012?
Give a very brief answer. 0.92. What is the ratio of the Balance of Payment (as % of commercial service exports) in Australia in 2011 to that in 2012?
Your answer should be compact. 1.04. What is the ratio of the Balance of Payment (as % of commercial service exports) of Guyana in 2011 to that in 2012?
Offer a very short reply. 0.91. What is the ratio of the Balance of Payment (as % of commercial service exports) of Paraguay in 2011 to that in 2012?
Your answer should be very brief. 0.99. What is the difference between the highest and the second highest Balance of Payment (as % of commercial service exports) in Australia?
Make the answer very short. 0.87. What is the difference between the highest and the second highest Balance of Payment (as % of commercial service exports) in Guyana?
Keep it short and to the point. 0.64. What is the difference between the highest and the second highest Balance of Payment (as % of commercial service exports) in Paraguay?
Your response must be concise. 7.47. What is the difference between the highest and the lowest Balance of Payment (as % of commercial service exports) of Australia?
Ensure brevity in your answer.  6.53. What is the difference between the highest and the lowest Balance of Payment (as % of commercial service exports) of Guyana?
Your answer should be very brief. 2.63. What is the difference between the highest and the lowest Balance of Payment (as % of commercial service exports) in Paraguay?
Ensure brevity in your answer.  22.09. 